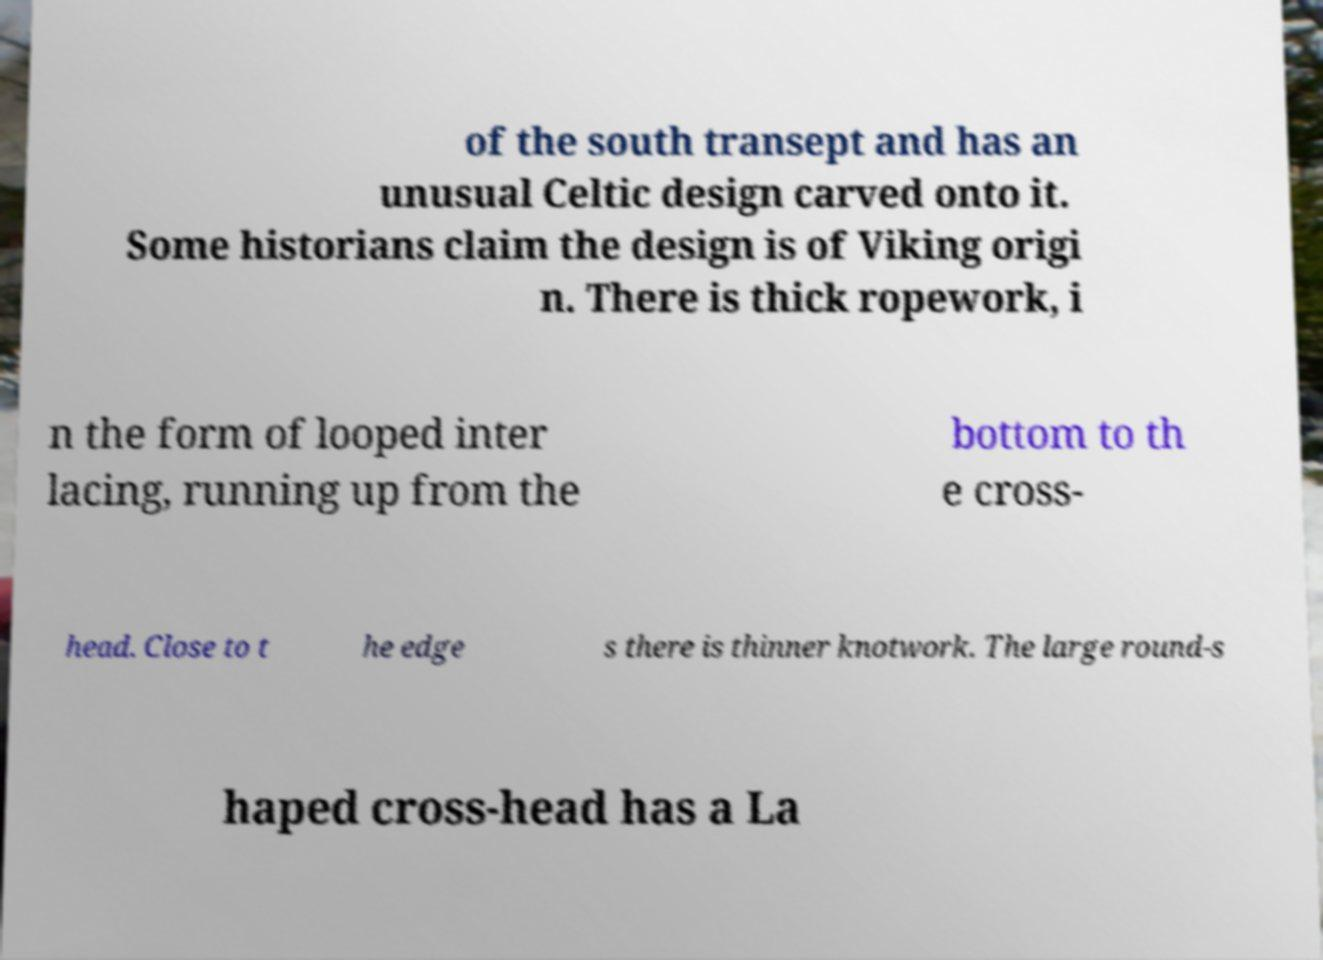Could you assist in decoding the text presented in this image and type it out clearly? of the south transept and has an unusual Celtic design carved onto it. Some historians claim the design is of Viking origi n. There is thick ropework, i n the form of looped inter lacing, running up from the bottom to th e cross- head. Close to t he edge s there is thinner knotwork. The large round-s haped cross-head has a La 